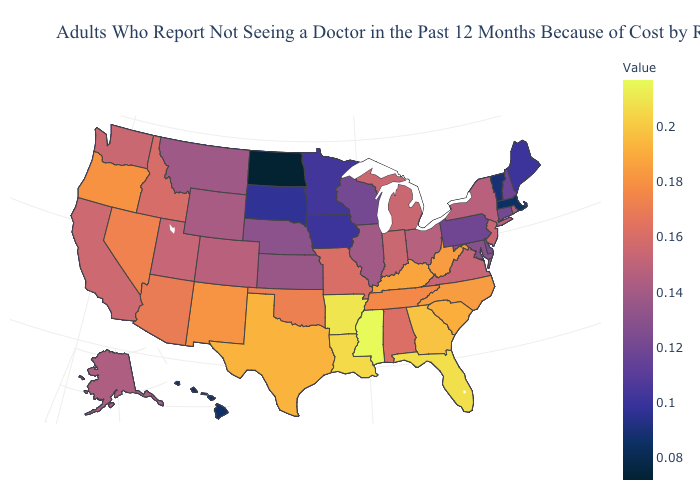Does Washington have the highest value in the USA?
Be succinct. No. Does New York have a lower value than South Carolina?
Concise answer only. Yes. Does Vermont have a lower value than North Dakota?
Be succinct. No. Among the states that border North Carolina , does Georgia have the highest value?
Short answer required. Yes. Which states hav the highest value in the MidWest?
Quick response, please. Missouri. Does North Dakota have the lowest value in the USA?
Give a very brief answer. Yes. 